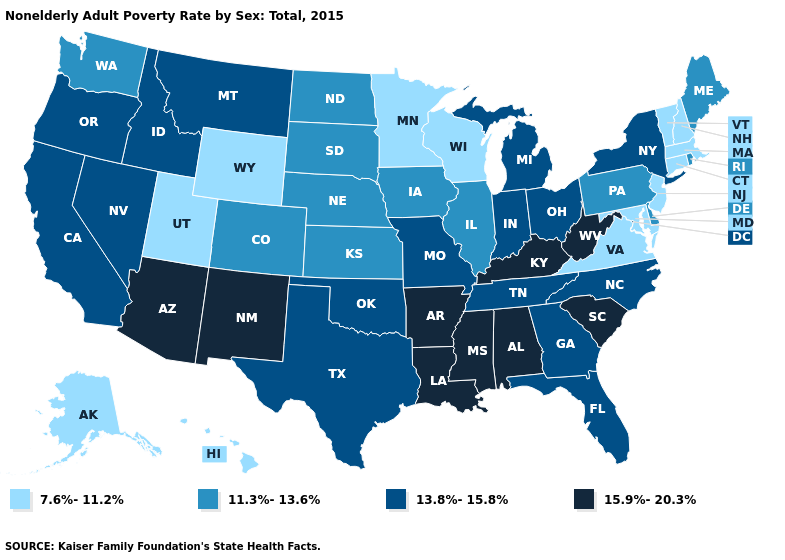What is the value of South Dakota?
Concise answer only. 11.3%-13.6%. Among the states that border Connecticut , does Rhode Island have the lowest value?
Concise answer only. No. What is the value of Montana?
Short answer required. 13.8%-15.8%. Name the states that have a value in the range 11.3%-13.6%?
Quick response, please. Colorado, Delaware, Illinois, Iowa, Kansas, Maine, Nebraska, North Dakota, Pennsylvania, Rhode Island, South Dakota, Washington. What is the value of Kentucky?
Answer briefly. 15.9%-20.3%. Does North Dakota have a lower value than Ohio?
Keep it brief. Yes. How many symbols are there in the legend?
Concise answer only. 4. What is the highest value in the USA?
Answer briefly. 15.9%-20.3%. Which states have the lowest value in the MidWest?
Write a very short answer. Minnesota, Wisconsin. Does the first symbol in the legend represent the smallest category?
Give a very brief answer. Yes. What is the highest value in the USA?
Write a very short answer. 15.9%-20.3%. What is the highest value in the USA?
Short answer required. 15.9%-20.3%. What is the value of Virginia?
Answer briefly. 7.6%-11.2%. Name the states that have a value in the range 13.8%-15.8%?
Concise answer only. California, Florida, Georgia, Idaho, Indiana, Michigan, Missouri, Montana, Nevada, New York, North Carolina, Ohio, Oklahoma, Oregon, Tennessee, Texas. What is the value of New Jersey?
Write a very short answer. 7.6%-11.2%. 